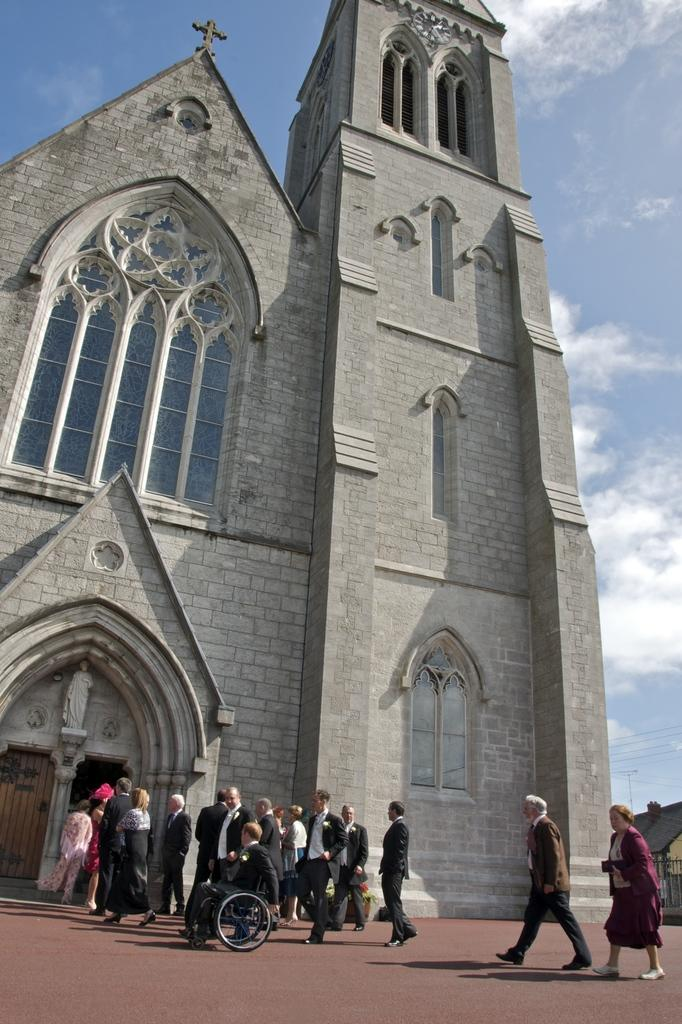What type of building is in the image? There is a church in the image. Are there any people present in the image? Yes, there are people at the bottom of the image. What can be seen in the background of the image? The sky is visible in the background of the image. What type of juice is being served at the church in the image? There is no juice or indication of any refreshments being served in the image. 